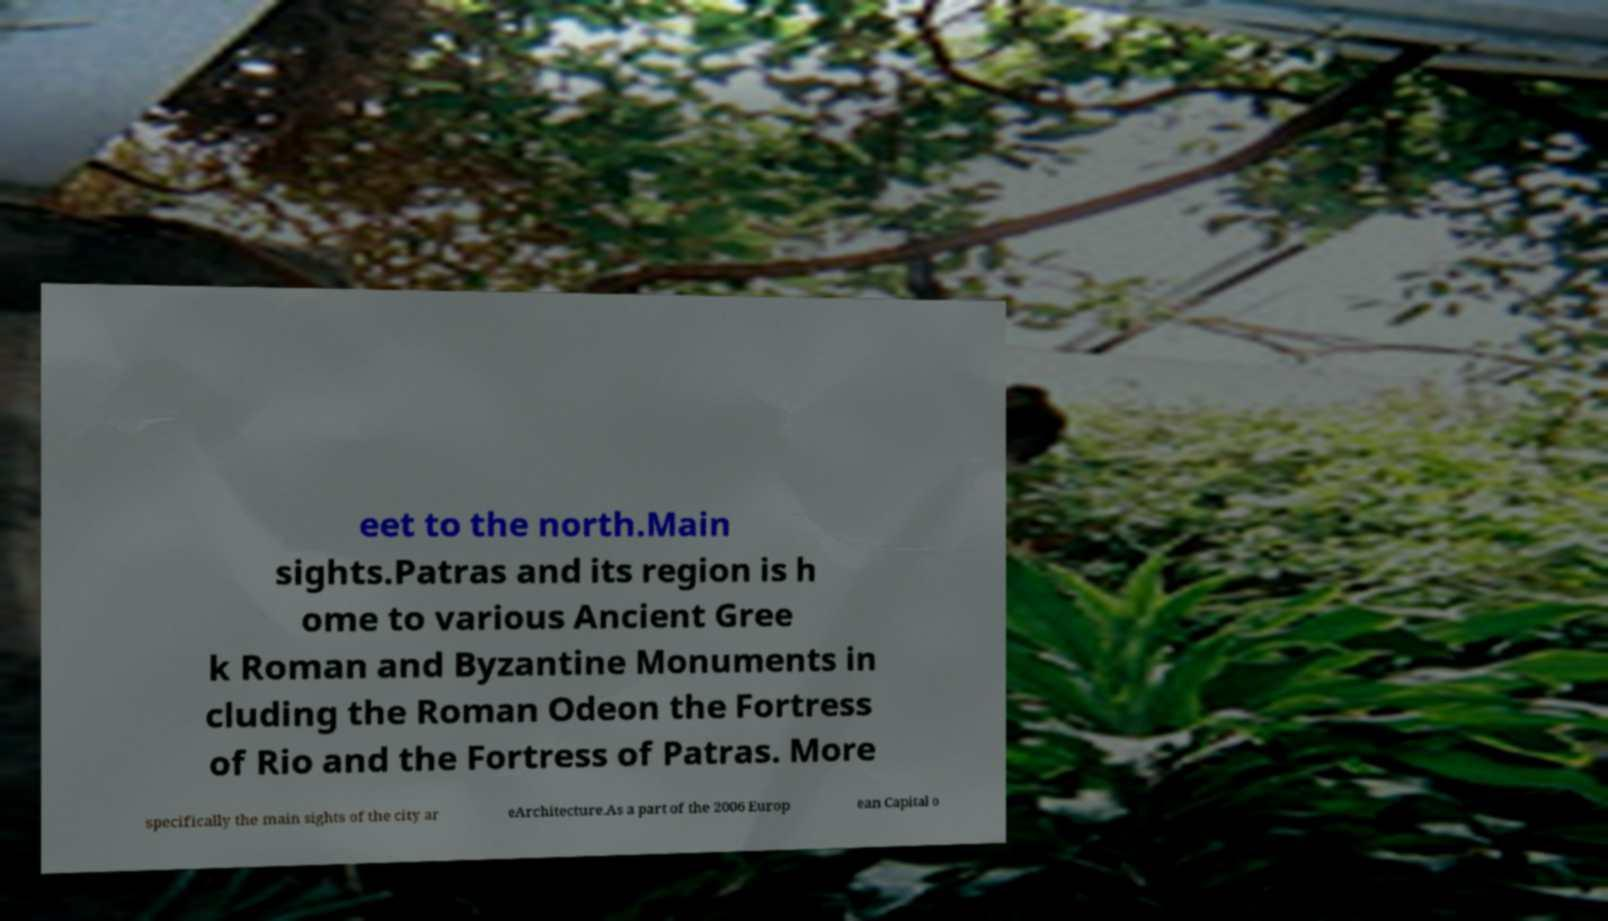Can you accurately transcribe the text from the provided image for me? eet to the north.Main sights.Patras and its region is h ome to various Ancient Gree k Roman and Byzantine Monuments in cluding the Roman Odeon the Fortress of Rio and the Fortress of Patras. More specifically the main sights of the city ar eArchitecture.As a part of the 2006 Europ ean Capital o 